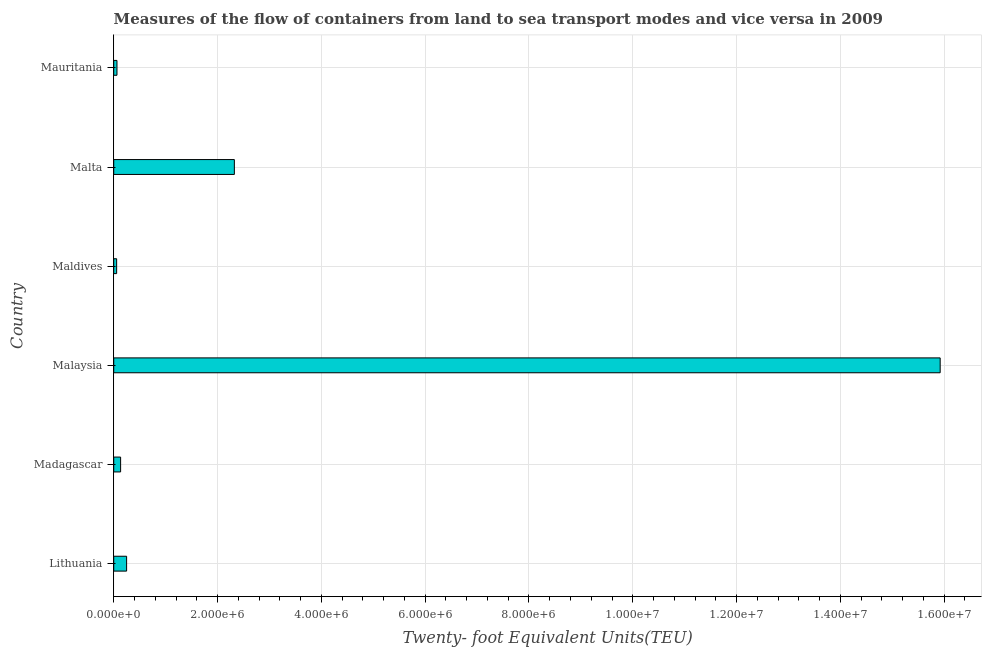Does the graph contain any zero values?
Provide a short and direct response. No. Does the graph contain grids?
Make the answer very short. Yes. What is the title of the graph?
Ensure brevity in your answer.  Measures of the flow of containers from land to sea transport modes and vice versa in 2009. What is the label or title of the X-axis?
Your answer should be very brief. Twenty- foot Equivalent Units(TEU). What is the label or title of the Y-axis?
Keep it short and to the point. Country. What is the container port traffic in Malta?
Your answer should be compact. 2.32e+06. Across all countries, what is the maximum container port traffic?
Offer a terse response. 1.59e+07. Across all countries, what is the minimum container port traffic?
Provide a short and direct response. 5.60e+04. In which country was the container port traffic maximum?
Offer a terse response. Malaysia. In which country was the container port traffic minimum?
Your answer should be compact. Maldives. What is the sum of the container port traffic?
Keep it short and to the point. 1.87e+07. What is the difference between the container port traffic in Malta and Mauritania?
Your answer should be compact. 2.26e+06. What is the average container port traffic per country?
Keep it short and to the point. 3.12e+06. What is the median container port traffic?
Keep it short and to the point. 1.90e+05. In how many countries, is the container port traffic greater than 6400000 TEU?
Offer a very short reply. 1. What is the ratio of the container port traffic in Malta to that in Mauritania?
Ensure brevity in your answer.  37.32. Is the container port traffic in Lithuania less than that in Maldives?
Offer a terse response. No. What is the difference between the highest and the second highest container port traffic?
Keep it short and to the point. 1.36e+07. Is the sum of the container port traffic in Lithuania and Mauritania greater than the maximum container port traffic across all countries?
Keep it short and to the point. No. What is the difference between the highest and the lowest container port traffic?
Make the answer very short. 1.59e+07. How many bars are there?
Offer a very short reply. 6. How many countries are there in the graph?
Provide a succinct answer. 6. What is the difference between two consecutive major ticks on the X-axis?
Make the answer very short. 2.00e+06. Are the values on the major ticks of X-axis written in scientific E-notation?
Provide a succinct answer. Yes. What is the Twenty- foot Equivalent Units(TEU) in Lithuania?
Ensure brevity in your answer.  2.48e+05. What is the Twenty- foot Equivalent Units(TEU) in Madagascar?
Offer a terse response. 1.32e+05. What is the Twenty- foot Equivalent Units(TEU) in Malaysia?
Provide a short and direct response. 1.59e+07. What is the Twenty- foot Equivalent Units(TEU) in Maldives?
Offer a terse response. 5.60e+04. What is the Twenty- foot Equivalent Units(TEU) in Malta?
Your answer should be very brief. 2.32e+06. What is the Twenty- foot Equivalent Units(TEU) in Mauritania?
Provide a short and direct response. 6.23e+04. What is the difference between the Twenty- foot Equivalent Units(TEU) in Lithuania and Madagascar?
Give a very brief answer. 1.16e+05. What is the difference between the Twenty- foot Equivalent Units(TEU) in Lithuania and Malaysia?
Your answer should be very brief. -1.57e+07. What is the difference between the Twenty- foot Equivalent Units(TEU) in Lithuania and Maldives?
Your answer should be very brief. 1.92e+05. What is the difference between the Twenty- foot Equivalent Units(TEU) in Lithuania and Malta?
Your answer should be very brief. -2.08e+06. What is the difference between the Twenty- foot Equivalent Units(TEU) in Lithuania and Mauritania?
Offer a terse response. 1.86e+05. What is the difference between the Twenty- foot Equivalent Units(TEU) in Madagascar and Malaysia?
Make the answer very short. -1.58e+07. What is the difference between the Twenty- foot Equivalent Units(TEU) in Madagascar and Maldives?
Give a very brief answer. 7.63e+04. What is the difference between the Twenty- foot Equivalent Units(TEU) in Madagascar and Malta?
Provide a succinct answer. -2.19e+06. What is the difference between the Twenty- foot Equivalent Units(TEU) in Madagascar and Mauritania?
Your response must be concise. 7.00e+04. What is the difference between the Twenty- foot Equivalent Units(TEU) in Malaysia and Maldives?
Your answer should be compact. 1.59e+07. What is the difference between the Twenty- foot Equivalent Units(TEU) in Malaysia and Malta?
Provide a succinct answer. 1.36e+07. What is the difference between the Twenty- foot Equivalent Units(TEU) in Malaysia and Mauritania?
Make the answer very short. 1.59e+07. What is the difference between the Twenty- foot Equivalent Units(TEU) in Maldives and Malta?
Your answer should be compact. -2.27e+06. What is the difference between the Twenty- foot Equivalent Units(TEU) in Maldives and Mauritania?
Offer a terse response. -6269. What is the difference between the Twenty- foot Equivalent Units(TEU) in Malta and Mauritania?
Provide a succinct answer. 2.26e+06. What is the ratio of the Twenty- foot Equivalent Units(TEU) in Lithuania to that in Madagascar?
Your answer should be very brief. 1.88. What is the ratio of the Twenty- foot Equivalent Units(TEU) in Lithuania to that in Malaysia?
Your answer should be compact. 0.02. What is the ratio of the Twenty- foot Equivalent Units(TEU) in Lithuania to that in Maldives?
Make the answer very short. 4.43. What is the ratio of the Twenty- foot Equivalent Units(TEU) in Lithuania to that in Malta?
Offer a very short reply. 0.11. What is the ratio of the Twenty- foot Equivalent Units(TEU) in Lithuania to that in Mauritania?
Your answer should be very brief. 3.98. What is the ratio of the Twenty- foot Equivalent Units(TEU) in Madagascar to that in Malaysia?
Your response must be concise. 0.01. What is the ratio of the Twenty- foot Equivalent Units(TEU) in Madagascar to that in Maldives?
Your answer should be very brief. 2.36. What is the ratio of the Twenty- foot Equivalent Units(TEU) in Madagascar to that in Malta?
Ensure brevity in your answer.  0.06. What is the ratio of the Twenty- foot Equivalent Units(TEU) in Madagascar to that in Mauritania?
Keep it short and to the point. 2.12. What is the ratio of the Twenty- foot Equivalent Units(TEU) in Malaysia to that in Maldives?
Provide a succinct answer. 284.34. What is the ratio of the Twenty- foot Equivalent Units(TEU) in Malaysia to that in Malta?
Offer a very short reply. 6.85. What is the ratio of the Twenty- foot Equivalent Units(TEU) in Malaysia to that in Mauritania?
Ensure brevity in your answer.  255.71. What is the ratio of the Twenty- foot Equivalent Units(TEU) in Maldives to that in Malta?
Ensure brevity in your answer.  0.02. What is the ratio of the Twenty- foot Equivalent Units(TEU) in Maldives to that in Mauritania?
Provide a short and direct response. 0.9. What is the ratio of the Twenty- foot Equivalent Units(TEU) in Malta to that in Mauritania?
Make the answer very short. 37.32. 